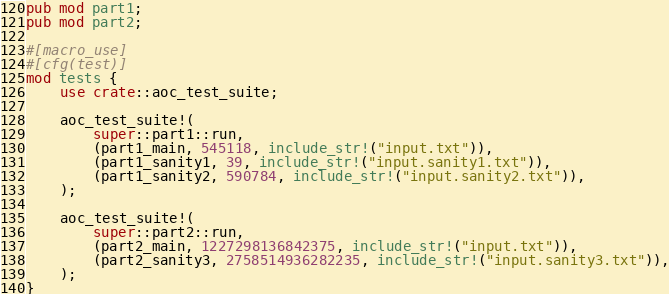Convert code to text. <code><loc_0><loc_0><loc_500><loc_500><_Rust_>pub mod part1;
pub mod part2;

#[macro_use]
#[cfg(test)]
mod tests {
    use crate::aoc_test_suite;

    aoc_test_suite!(
        super::part1::run,
        (part1_main, 545118, include_str!("input.txt")),
        (part1_sanity1, 39, include_str!("input.sanity1.txt")),
        (part1_sanity2, 590784, include_str!("input.sanity2.txt")),
    );

    aoc_test_suite!(
        super::part2::run,
        (part2_main, 1227298136842375, include_str!("input.txt")),
        (part2_sanity3, 2758514936282235, include_str!("input.sanity3.txt")),
    );
}
</code> 